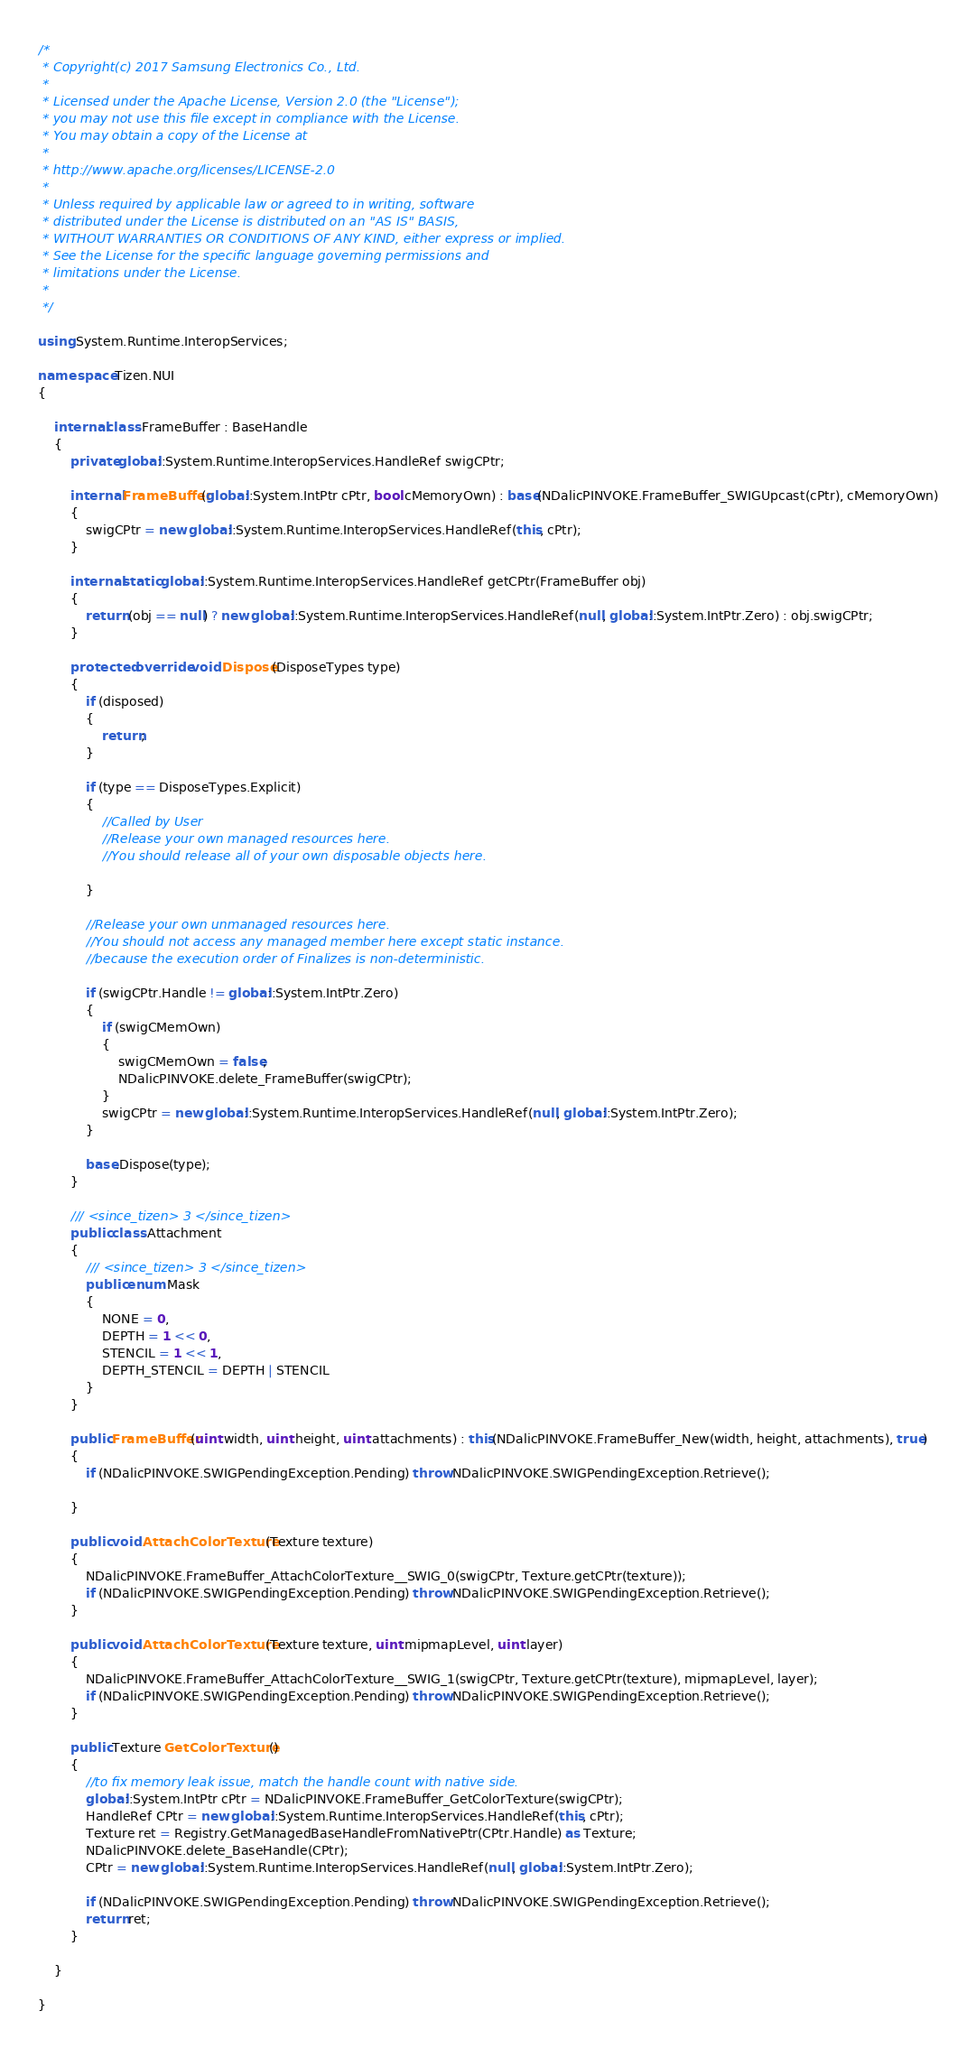<code> <loc_0><loc_0><loc_500><loc_500><_C#_>/*
 * Copyright(c) 2017 Samsung Electronics Co., Ltd.
 *
 * Licensed under the Apache License, Version 2.0 (the "License");
 * you may not use this file except in compliance with the License.
 * You may obtain a copy of the License at
 *
 * http://www.apache.org/licenses/LICENSE-2.0
 *
 * Unless required by applicable law or agreed to in writing, software
 * distributed under the License is distributed on an "AS IS" BASIS,
 * WITHOUT WARRANTIES OR CONDITIONS OF ANY KIND, either express or implied.
 * See the License for the specific language governing permissions and
 * limitations under the License.
 *
 */

using System.Runtime.InteropServices;

namespace Tizen.NUI
{

    internal class FrameBuffer : BaseHandle
    {
        private global::System.Runtime.InteropServices.HandleRef swigCPtr;

        internal FrameBuffer(global::System.IntPtr cPtr, bool cMemoryOwn) : base(NDalicPINVOKE.FrameBuffer_SWIGUpcast(cPtr), cMemoryOwn)
        {
            swigCPtr = new global::System.Runtime.InteropServices.HandleRef(this, cPtr);
        }

        internal static global::System.Runtime.InteropServices.HandleRef getCPtr(FrameBuffer obj)
        {
            return (obj == null) ? new global::System.Runtime.InteropServices.HandleRef(null, global::System.IntPtr.Zero) : obj.swigCPtr;
        }

        protected override void Dispose(DisposeTypes type)
        {
            if (disposed)
            {
                return;
            }

            if (type == DisposeTypes.Explicit)
            {
                //Called by User
                //Release your own managed resources here.
                //You should release all of your own disposable objects here.

            }

            //Release your own unmanaged resources here.
            //You should not access any managed member here except static instance.
            //because the execution order of Finalizes is non-deterministic.

            if (swigCPtr.Handle != global::System.IntPtr.Zero)
            {
                if (swigCMemOwn)
                {
                    swigCMemOwn = false;
                    NDalicPINVOKE.delete_FrameBuffer(swigCPtr);
                }
                swigCPtr = new global::System.Runtime.InteropServices.HandleRef(null, global::System.IntPtr.Zero);
            }

            base.Dispose(type);
        }

        /// <since_tizen> 3 </since_tizen>
        public class Attachment
        {
            /// <since_tizen> 3 </since_tizen>
            public enum Mask
            {
                NONE = 0,
                DEPTH = 1 << 0,
                STENCIL = 1 << 1,
                DEPTH_STENCIL = DEPTH | STENCIL
            }
        }

        public FrameBuffer(uint width, uint height, uint attachments) : this(NDalicPINVOKE.FrameBuffer_New(width, height, attachments), true)
        {
            if (NDalicPINVOKE.SWIGPendingException.Pending) throw NDalicPINVOKE.SWIGPendingException.Retrieve();

        }

        public void AttachColorTexture(Texture texture)
        {
            NDalicPINVOKE.FrameBuffer_AttachColorTexture__SWIG_0(swigCPtr, Texture.getCPtr(texture));
            if (NDalicPINVOKE.SWIGPendingException.Pending) throw NDalicPINVOKE.SWIGPendingException.Retrieve();
        }

        public void AttachColorTexture(Texture texture, uint mipmapLevel, uint layer)
        {
            NDalicPINVOKE.FrameBuffer_AttachColorTexture__SWIG_1(swigCPtr, Texture.getCPtr(texture), mipmapLevel, layer);
            if (NDalicPINVOKE.SWIGPendingException.Pending) throw NDalicPINVOKE.SWIGPendingException.Retrieve();
        }

        public Texture GetColorTexture()
        {
            //to fix memory leak issue, match the handle count with native side.
            global::System.IntPtr cPtr = NDalicPINVOKE.FrameBuffer_GetColorTexture(swigCPtr);
            HandleRef CPtr = new global::System.Runtime.InteropServices.HandleRef(this, cPtr);
            Texture ret = Registry.GetManagedBaseHandleFromNativePtr(CPtr.Handle) as Texture;
            NDalicPINVOKE.delete_BaseHandle(CPtr);
            CPtr = new global::System.Runtime.InteropServices.HandleRef(null, global::System.IntPtr.Zero);

            if (NDalicPINVOKE.SWIGPendingException.Pending) throw NDalicPINVOKE.SWIGPendingException.Retrieve();
            return ret;
        }

    }

}
</code> 